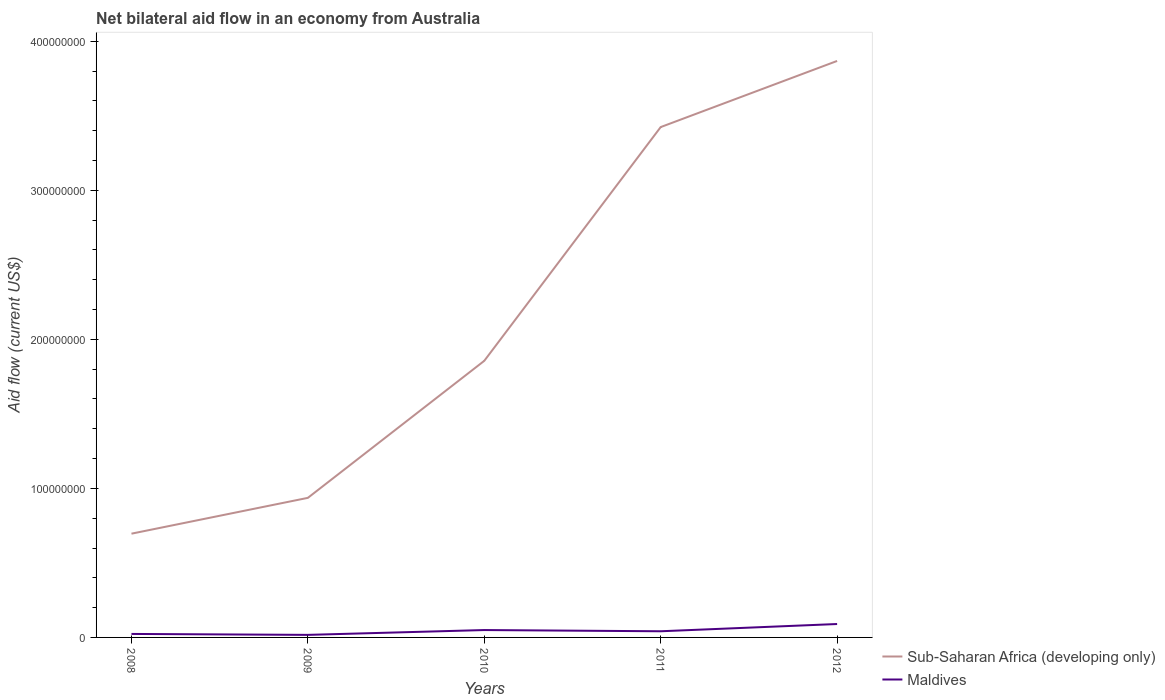How many different coloured lines are there?
Keep it short and to the point. 2. Is the number of lines equal to the number of legend labels?
Your answer should be compact. Yes. Across all years, what is the maximum net bilateral aid flow in Sub-Saharan Africa (developing only)?
Ensure brevity in your answer.  6.96e+07. In which year was the net bilateral aid flow in Maldives maximum?
Your answer should be very brief. 2009. What is the total net bilateral aid flow in Sub-Saharan Africa (developing only) in the graph?
Your answer should be compact. -2.73e+08. What is the difference between the highest and the second highest net bilateral aid flow in Maldives?
Provide a succinct answer. 7.29e+06. What is the difference between the highest and the lowest net bilateral aid flow in Maldives?
Your answer should be very brief. 2. How many years are there in the graph?
Offer a terse response. 5. What is the difference between two consecutive major ticks on the Y-axis?
Keep it short and to the point. 1.00e+08. Are the values on the major ticks of Y-axis written in scientific E-notation?
Provide a succinct answer. No. Does the graph contain any zero values?
Your answer should be very brief. No. How many legend labels are there?
Your answer should be very brief. 2. How are the legend labels stacked?
Make the answer very short. Vertical. What is the title of the graph?
Offer a terse response. Net bilateral aid flow in an economy from Australia. Does "Guinea" appear as one of the legend labels in the graph?
Your answer should be compact. No. What is the label or title of the Y-axis?
Provide a succinct answer. Aid flow (current US$). What is the Aid flow (current US$) of Sub-Saharan Africa (developing only) in 2008?
Give a very brief answer. 6.96e+07. What is the Aid flow (current US$) in Maldives in 2008?
Your answer should be compact. 2.34e+06. What is the Aid flow (current US$) of Sub-Saharan Africa (developing only) in 2009?
Your response must be concise. 9.36e+07. What is the Aid flow (current US$) of Maldives in 2009?
Your answer should be compact. 1.71e+06. What is the Aid flow (current US$) in Sub-Saharan Africa (developing only) in 2010?
Offer a terse response. 1.86e+08. What is the Aid flow (current US$) of Maldives in 2010?
Ensure brevity in your answer.  4.95e+06. What is the Aid flow (current US$) in Sub-Saharan Africa (developing only) in 2011?
Give a very brief answer. 3.42e+08. What is the Aid flow (current US$) in Maldives in 2011?
Make the answer very short. 4.13e+06. What is the Aid flow (current US$) in Sub-Saharan Africa (developing only) in 2012?
Keep it short and to the point. 3.87e+08. What is the Aid flow (current US$) in Maldives in 2012?
Provide a short and direct response. 9.00e+06. Across all years, what is the maximum Aid flow (current US$) in Sub-Saharan Africa (developing only)?
Provide a short and direct response. 3.87e+08. Across all years, what is the maximum Aid flow (current US$) of Maldives?
Your answer should be compact. 9.00e+06. Across all years, what is the minimum Aid flow (current US$) of Sub-Saharan Africa (developing only)?
Ensure brevity in your answer.  6.96e+07. Across all years, what is the minimum Aid flow (current US$) in Maldives?
Give a very brief answer. 1.71e+06. What is the total Aid flow (current US$) of Sub-Saharan Africa (developing only) in the graph?
Offer a very short reply. 1.08e+09. What is the total Aid flow (current US$) of Maldives in the graph?
Offer a terse response. 2.21e+07. What is the difference between the Aid flow (current US$) in Sub-Saharan Africa (developing only) in 2008 and that in 2009?
Your response must be concise. -2.40e+07. What is the difference between the Aid flow (current US$) in Maldives in 2008 and that in 2009?
Give a very brief answer. 6.30e+05. What is the difference between the Aid flow (current US$) of Sub-Saharan Africa (developing only) in 2008 and that in 2010?
Offer a terse response. -1.16e+08. What is the difference between the Aid flow (current US$) of Maldives in 2008 and that in 2010?
Keep it short and to the point. -2.61e+06. What is the difference between the Aid flow (current US$) in Sub-Saharan Africa (developing only) in 2008 and that in 2011?
Your answer should be very brief. -2.73e+08. What is the difference between the Aid flow (current US$) in Maldives in 2008 and that in 2011?
Give a very brief answer. -1.79e+06. What is the difference between the Aid flow (current US$) in Sub-Saharan Africa (developing only) in 2008 and that in 2012?
Provide a succinct answer. -3.17e+08. What is the difference between the Aid flow (current US$) of Maldives in 2008 and that in 2012?
Offer a terse response. -6.66e+06. What is the difference between the Aid flow (current US$) of Sub-Saharan Africa (developing only) in 2009 and that in 2010?
Make the answer very short. -9.20e+07. What is the difference between the Aid flow (current US$) in Maldives in 2009 and that in 2010?
Offer a very short reply. -3.24e+06. What is the difference between the Aid flow (current US$) of Sub-Saharan Africa (developing only) in 2009 and that in 2011?
Make the answer very short. -2.49e+08. What is the difference between the Aid flow (current US$) in Maldives in 2009 and that in 2011?
Offer a terse response. -2.42e+06. What is the difference between the Aid flow (current US$) in Sub-Saharan Africa (developing only) in 2009 and that in 2012?
Offer a terse response. -2.93e+08. What is the difference between the Aid flow (current US$) in Maldives in 2009 and that in 2012?
Offer a terse response. -7.29e+06. What is the difference between the Aid flow (current US$) of Sub-Saharan Africa (developing only) in 2010 and that in 2011?
Provide a short and direct response. -1.57e+08. What is the difference between the Aid flow (current US$) of Maldives in 2010 and that in 2011?
Your answer should be compact. 8.20e+05. What is the difference between the Aid flow (current US$) in Sub-Saharan Africa (developing only) in 2010 and that in 2012?
Make the answer very short. -2.01e+08. What is the difference between the Aid flow (current US$) of Maldives in 2010 and that in 2012?
Ensure brevity in your answer.  -4.05e+06. What is the difference between the Aid flow (current US$) in Sub-Saharan Africa (developing only) in 2011 and that in 2012?
Make the answer very short. -4.44e+07. What is the difference between the Aid flow (current US$) of Maldives in 2011 and that in 2012?
Your response must be concise. -4.87e+06. What is the difference between the Aid flow (current US$) of Sub-Saharan Africa (developing only) in 2008 and the Aid flow (current US$) of Maldives in 2009?
Ensure brevity in your answer.  6.79e+07. What is the difference between the Aid flow (current US$) of Sub-Saharan Africa (developing only) in 2008 and the Aid flow (current US$) of Maldives in 2010?
Your response must be concise. 6.47e+07. What is the difference between the Aid flow (current US$) of Sub-Saharan Africa (developing only) in 2008 and the Aid flow (current US$) of Maldives in 2011?
Your answer should be very brief. 6.55e+07. What is the difference between the Aid flow (current US$) of Sub-Saharan Africa (developing only) in 2008 and the Aid flow (current US$) of Maldives in 2012?
Keep it short and to the point. 6.06e+07. What is the difference between the Aid flow (current US$) of Sub-Saharan Africa (developing only) in 2009 and the Aid flow (current US$) of Maldives in 2010?
Your answer should be compact. 8.87e+07. What is the difference between the Aid flow (current US$) of Sub-Saharan Africa (developing only) in 2009 and the Aid flow (current US$) of Maldives in 2011?
Provide a short and direct response. 8.95e+07. What is the difference between the Aid flow (current US$) in Sub-Saharan Africa (developing only) in 2009 and the Aid flow (current US$) in Maldives in 2012?
Offer a terse response. 8.46e+07. What is the difference between the Aid flow (current US$) in Sub-Saharan Africa (developing only) in 2010 and the Aid flow (current US$) in Maldives in 2011?
Offer a terse response. 1.81e+08. What is the difference between the Aid flow (current US$) of Sub-Saharan Africa (developing only) in 2010 and the Aid flow (current US$) of Maldives in 2012?
Offer a very short reply. 1.77e+08. What is the difference between the Aid flow (current US$) in Sub-Saharan Africa (developing only) in 2011 and the Aid flow (current US$) in Maldives in 2012?
Offer a terse response. 3.33e+08. What is the average Aid flow (current US$) in Sub-Saharan Africa (developing only) per year?
Keep it short and to the point. 2.16e+08. What is the average Aid flow (current US$) in Maldives per year?
Offer a very short reply. 4.43e+06. In the year 2008, what is the difference between the Aid flow (current US$) of Sub-Saharan Africa (developing only) and Aid flow (current US$) of Maldives?
Provide a succinct answer. 6.73e+07. In the year 2009, what is the difference between the Aid flow (current US$) in Sub-Saharan Africa (developing only) and Aid flow (current US$) in Maldives?
Keep it short and to the point. 9.19e+07. In the year 2010, what is the difference between the Aid flow (current US$) in Sub-Saharan Africa (developing only) and Aid flow (current US$) in Maldives?
Your answer should be compact. 1.81e+08. In the year 2011, what is the difference between the Aid flow (current US$) in Sub-Saharan Africa (developing only) and Aid flow (current US$) in Maldives?
Keep it short and to the point. 3.38e+08. In the year 2012, what is the difference between the Aid flow (current US$) of Sub-Saharan Africa (developing only) and Aid flow (current US$) of Maldives?
Provide a short and direct response. 3.78e+08. What is the ratio of the Aid flow (current US$) in Sub-Saharan Africa (developing only) in 2008 to that in 2009?
Ensure brevity in your answer.  0.74. What is the ratio of the Aid flow (current US$) of Maldives in 2008 to that in 2009?
Your response must be concise. 1.37. What is the ratio of the Aid flow (current US$) of Sub-Saharan Africa (developing only) in 2008 to that in 2010?
Your answer should be very brief. 0.38. What is the ratio of the Aid flow (current US$) of Maldives in 2008 to that in 2010?
Ensure brevity in your answer.  0.47. What is the ratio of the Aid flow (current US$) in Sub-Saharan Africa (developing only) in 2008 to that in 2011?
Make the answer very short. 0.2. What is the ratio of the Aid flow (current US$) of Maldives in 2008 to that in 2011?
Offer a very short reply. 0.57. What is the ratio of the Aid flow (current US$) of Sub-Saharan Africa (developing only) in 2008 to that in 2012?
Your answer should be very brief. 0.18. What is the ratio of the Aid flow (current US$) in Maldives in 2008 to that in 2012?
Your response must be concise. 0.26. What is the ratio of the Aid flow (current US$) of Sub-Saharan Africa (developing only) in 2009 to that in 2010?
Ensure brevity in your answer.  0.5. What is the ratio of the Aid flow (current US$) in Maldives in 2009 to that in 2010?
Keep it short and to the point. 0.35. What is the ratio of the Aid flow (current US$) in Sub-Saharan Africa (developing only) in 2009 to that in 2011?
Keep it short and to the point. 0.27. What is the ratio of the Aid flow (current US$) of Maldives in 2009 to that in 2011?
Make the answer very short. 0.41. What is the ratio of the Aid flow (current US$) of Sub-Saharan Africa (developing only) in 2009 to that in 2012?
Your answer should be compact. 0.24. What is the ratio of the Aid flow (current US$) in Maldives in 2009 to that in 2012?
Make the answer very short. 0.19. What is the ratio of the Aid flow (current US$) in Sub-Saharan Africa (developing only) in 2010 to that in 2011?
Ensure brevity in your answer.  0.54. What is the ratio of the Aid flow (current US$) in Maldives in 2010 to that in 2011?
Keep it short and to the point. 1.2. What is the ratio of the Aid flow (current US$) of Sub-Saharan Africa (developing only) in 2010 to that in 2012?
Keep it short and to the point. 0.48. What is the ratio of the Aid flow (current US$) of Maldives in 2010 to that in 2012?
Your response must be concise. 0.55. What is the ratio of the Aid flow (current US$) of Sub-Saharan Africa (developing only) in 2011 to that in 2012?
Provide a succinct answer. 0.89. What is the ratio of the Aid flow (current US$) of Maldives in 2011 to that in 2012?
Offer a terse response. 0.46. What is the difference between the highest and the second highest Aid flow (current US$) of Sub-Saharan Africa (developing only)?
Keep it short and to the point. 4.44e+07. What is the difference between the highest and the second highest Aid flow (current US$) of Maldives?
Provide a short and direct response. 4.05e+06. What is the difference between the highest and the lowest Aid flow (current US$) of Sub-Saharan Africa (developing only)?
Make the answer very short. 3.17e+08. What is the difference between the highest and the lowest Aid flow (current US$) of Maldives?
Your response must be concise. 7.29e+06. 